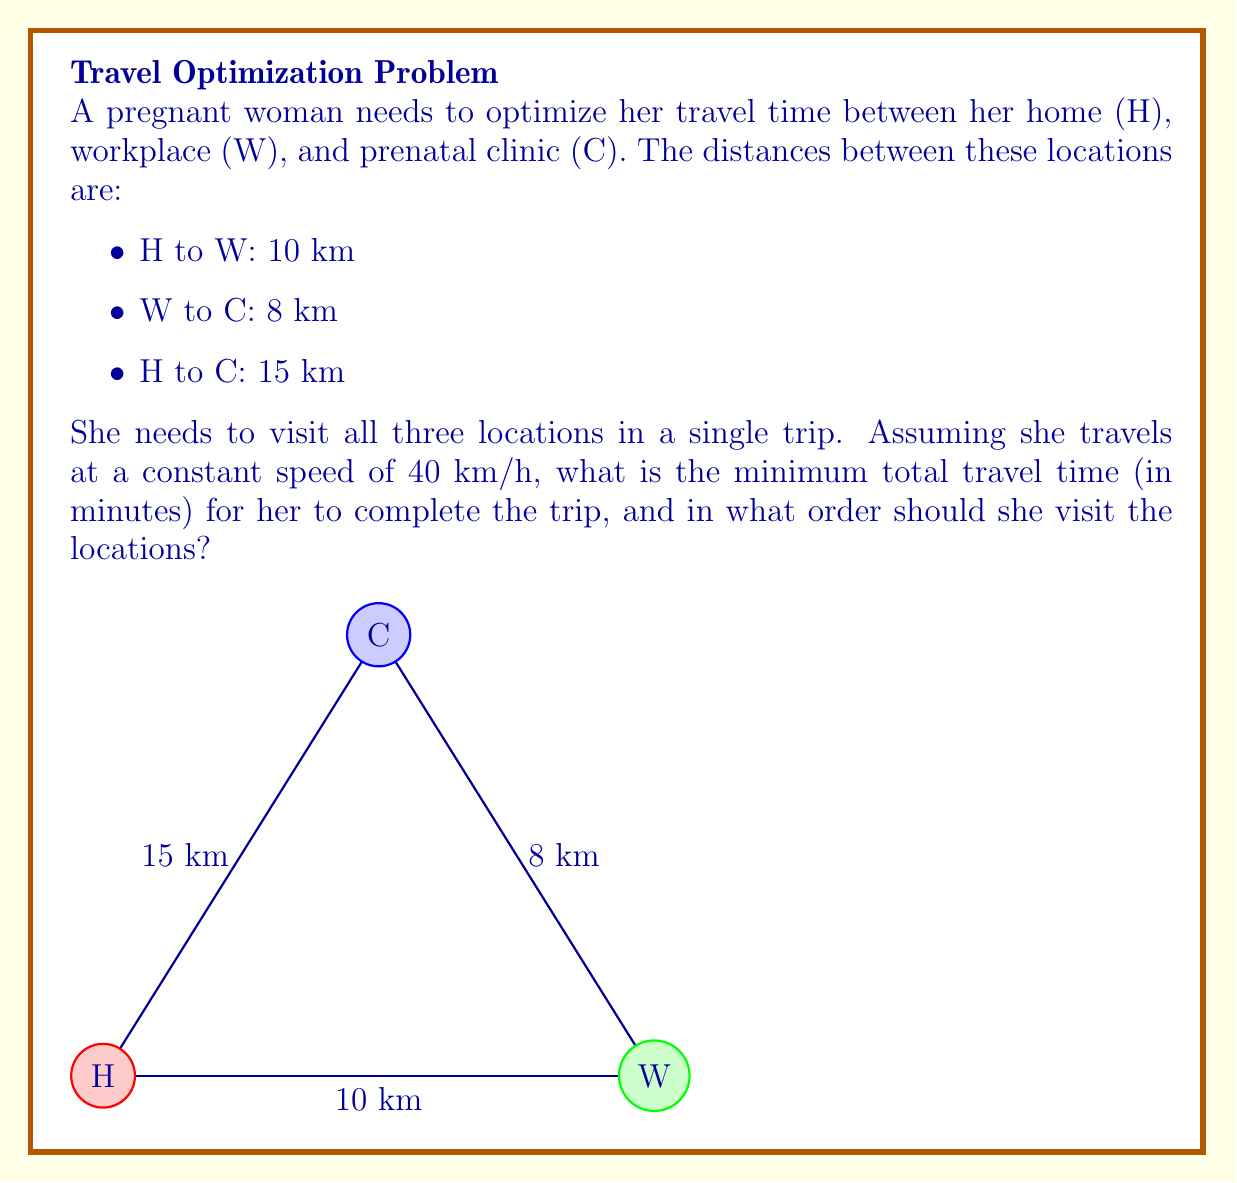What is the answer to this math problem? To solve this optimization problem, we need to consider all possible routes and calculate the total distance for each:

1. H → W → C → H
2. H → C → W → H
3. W → H → C → W
4. W → C → H → W
5. C → H → W → C
6. C → W → H → C

Let's calculate the total distance for each route:

1. H → W → C → H: 10 + 8 + 15 = 33 km
2. H → C → W → H: 15 + 8 + 10 = 33 km
3. W → H → C → W: 10 + 15 + 8 = 33 km
4. W → C → H → W: 8 + 15 + 10 = 33 km
5. C → H → W → C: 15 + 10 + 8 = 33 km
6. C → W → H → C: 8 + 10 + 15 = 33 km

We can see that all routes have the same total distance of 33 km. This is because the problem forms a triangle, and the sum of distances will always be the same regardless of the order of visits.

To calculate the travel time, we use the formula:

$$ \text{Time} = \frac{\text{Distance}}{\text{Speed}} $$

Substituting the values:

$$ \text{Time} = \frac{33 \text{ km}}{40 \text{ km/h}} = 0.825 \text{ hours} $$

Converting to minutes:

$$ 0.825 \text{ hours} \times 60 \text{ minutes/hour} = 49.5 \text{ minutes} $$

Since all routes take the same time, the woman can choose any order that fits her schedule best.
Answer: The minimum total travel time is 49.5 minutes. The woman can visit the locations in any order, as all routes result in the same total distance and time. 